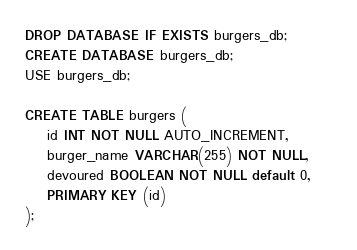Convert code to text. <code><loc_0><loc_0><loc_500><loc_500><_SQL_>DROP DATABASE IF EXISTS burgers_db;
CREATE DATABASE burgers_db;
USE burgers_db;

CREATE TABLE burgers (
    id INT NOT NULL AUTO_INCREMENT,
    burger_name VARCHAR(255) NOT NULL,
    devoured BOOLEAN NOT NULL default 0,    
    PRIMARY KEY (id) 
);</code> 